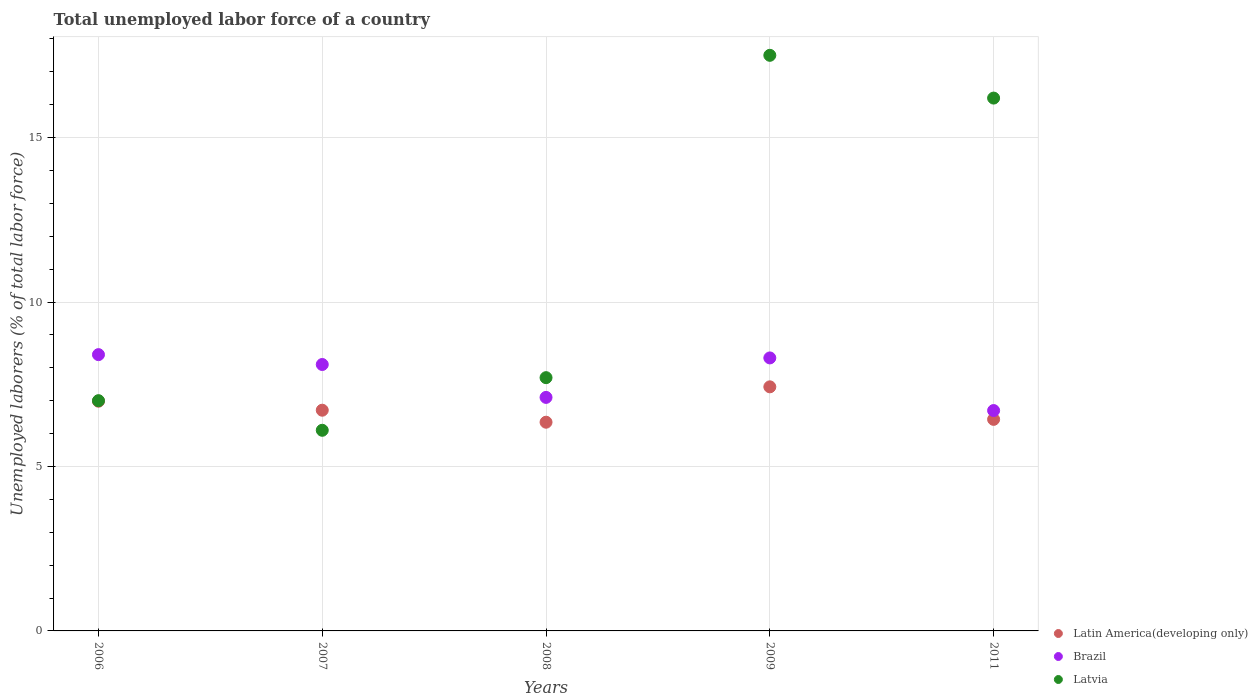How many different coloured dotlines are there?
Provide a short and direct response. 3. Is the number of dotlines equal to the number of legend labels?
Keep it short and to the point. Yes. What is the total unemployed labor force in Latin America(developing only) in 2011?
Offer a terse response. 6.43. Across all years, what is the maximum total unemployed labor force in Brazil?
Give a very brief answer. 8.4. Across all years, what is the minimum total unemployed labor force in Latin America(developing only)?
Ensure brevity in your answer.  6.35. In which year was the total unemployed labor force in Latvia maximum?
Your answer should be compact. 2009. In which year was the total unemployed labor force in Brazil minimum?
Keep it short and to the point. 2011. What is the total total unemployed labor force in Brazil in the graph?
Provide a succinct answer. 38.6. What is the difference between the total unemployed labor force in Latvia in 2006 and that in 2008?
Keep it short and to the point. -0.7. What is the difference between the total unemployed labor force in Brazil in 2006 and the total unemployed labor force in Latvia in 2007?
Offer a terse response. 2.3. What is the average total unemployed labor force in Latvia per year?
Ensure brevity in your answer.  10.9. In the year 2007, what is the difference between the total unemployed labor force in Brazil and total unemployed labor force in Latvia?
Your response must be concise. 2. In how many years, is the total unemployed labor force in Latvia greater than 1 %?
Your response must be concise. 5. What is the ratio of the total unemployed labor force in Latvia in 2009 to that in 2011?
Offer a very short reply. 1.08. Is the difference between the total unemployed labor force in Brazil in 2007 and 2008 greater than the difference between the total unemployed labor force in Latvia in 2007 and 2008?
Offer a terse response. Yes. What is the difference between the highest and the second highest total unemployed labor force in Latvia?
Provide a succinct answer. 1.3. What is the difference between the highest and the lowest total unemployed labor force in Latvia?
Give a very brief answer. 11.4. Is the sum of the total unemployed labor force in Brazil in 2007 and 2008 greater than the maximum total unemployed labor force in Latin America(developing only) across all years?
Your response must be concise. Yes. Is it the case that in every year, the sum of the total unemployed labor force in Brazil and total unemployed labor force in Latvia  is greater than the total unemployed labor force in Latin America(developing only)?
Keep it short and to the point. Yes. Is the total unemployed labor force in Brazil strictly greater than the total unemployed labor force in Latvia over the years?
Make the answer very short. No. Is the total unemployed labor force in Latvia strictly less than the total unemployed labor force in Latin America(developing only) over the years?
Your answer should be compact. No. How many dotlines are there?
Ensure brevity in your answer.  3. How many years are there in the graph?
Your response must be concise. 5. Does the graph contain any zero values?
Provide a succinct answer. No. Where does the legend appear in the graph?
Ensure brevity in your answer.  Bottom right. How are the legend labels stacked?
Provide a short and direct response. Vertical. What is the title of the graph?
Provide a short and direct response. Total unemployed labor force of a country. Does "Sub-Saharan Africa (all income levels)" appear as one of the legend labels in the graph?
Give a very brief answer. No. What is the label or title of the Y-axis?
Provide a succinct answer. Unemployed laborers (% of total labor force). What is the Unemployed laborers (% of total labor force) of Latin America(developing only) in 2006?
Keep it short and to the point. 6.98. What is the Unemployed laborers (% of total labor force) of Brazil in 2006?
Keep it short and to the point. 8.4. What is the Unemployed laborers (% of total labor force) in Latin America(developing only) in 2007?
Offer a terse response. 6.71. What is the Unemployed laborers (% of total labor force) of Brazil in 2007?
Give a very brief answer. 8.1. What is the Unemployed laborers (% of total labor force) of Latvia in 2007?
Ensure brevity in your answer.  6.1. What is the Unemployed laborers (% of total labor force) in Latin America(developing only) in 2008?
Make the answer very short. 6.35. What is the Unemployed laborers (% of total labor force) in Brazil in 2008?
Your answer should be very brief. 7.1. What is the Unemployed laborers (% of total labor force) of Latvia in 2008?
Provide a succinct answer. 7.7. What is the Unemployed laborers (% of total labor force) in Latin America(developing only) in 2009?
Your answer should be very brief. 7.42. What is the Unemployed laborers (% of total labor force) of Brazil in 2009?
Offer a very short reply. 8.3. What is the Unemployed laborers (% of total labor force) in Latin America(developing only) in 2011?
Offer a terse response. 6.43. What is the Unemployed laborers (% of total labor force) in Brazil in 2011?
Your response must be concise. 6.7. What is the Unemployed laborers (% of total labor force) in Latvia in 2011?
Give a very brief answer. 16.2. Across all years, what is the maximum Unemployed laborers (% of total labor force) in Latin America(developing only)?
Your answer should be very brief. 7.42. Across all years, what is the maximum Unemployed laborers (% of total labor force) in Brazil?
Provide a succinct answer. 8.4. Across all years, what is the maximum Unemployed laborers (% of total labor force) of Latvia?
Your answer should be very brief. 17.5. Across all years, what is the minimum Unemployed laborers (% of total labor force) of Latin America(developing only)?
Your answer should be very brief. 6.35. Across all years, what is the minimum Unemployed laborers (% of total labor force) in Brazil?
Offer a terse response. 6.7. Across all years, what is the minimum Unemployed laborers (% of total labor force) of Latvia?
Make the answer very short. 6.1. What is the total Unemployed laborers (% of total labor force) in Latin America(developing only) in the graph?
Your answer should be compact. 33.89. What is the total Unemployed laborers (% of total labor force) in Brazil in the graph?
Give a very brief answer. 38.6. What is the total Unemployed laborers (% of total labor force) in Latvia in the graph?
Make the answer very short. 54.5. What is the difference between the Unemployed laborers (% of total labor force) in Latin America(developing only) in 2006 and that in 2007?
Give a very brief answer. 0.27. What is the difference between the Unemployed laborers (% of total labor force) in Brazil in 2006 and that in 2007?
Ensure brevity in your answer.  0.3. What is the difference between the Unemployed laborers (% of total labor force) in Latvia in 2006 and that in 2007?
Make the answer very short. 0.9. What is the difference between the Unemployed laborers (% of total labor force) of Latin America(developing only) in 2006 and that in 2008?
Provide a succinct answer. 0.64. What is the difference between the Unemployed laborers (% of total labor force) in Brazil in 2006 and that in 2008?
Offer a very short reply. 1.3. What is the difference between the Unemployed laborers (% of total labor force) in Latin America(developing only) in 2006 and that in 2009?
Your response must be concise. -0.44. What is the difference between the Unemployed laborers (% of total labor force) of Latin America(developing only) in 2006 and that in 2011?
Offer a terse response. 0.55. What is the difference between the Unemployed laborers (% of total labor force) in Brazil in 2006 and that in 2011?
Provide a short and direct response. 1.7. What is the difference between the Unemployed laborers (% of total labor force) of Latin America(developing only) in 2007 and that in 2008?
Offer a terse response. 0.36. What is the difference between the Unemployed laborers (% of total labor force) in Brazil in 2007 and that in 2008?
Your response must be concise. 1. What is the difference between the Unemployed laborers (% of total labor force) in Latvia in 2007 and that in 2008?
Ensure brevity in your answer.  -1.6. What is the difference between the Unemployed laborers (% of total labor force) in Latin America(developing only) in 2007 and that in 2009?
Ensure brevity in your answer.  -0.71. What is the difference between the Unemployed laborers (% of total labor force) of Latin America(developing only) in 2007 and that in 2011?
Make the answer very short. 0.28. What is the difference between the Unemployed laborers (% of total labor force) of Latin America(developing only) in 2008 and that in 2009?
Make the answer very short. -1.08. What is the difference between the Unemployed laborers (% of total labor force) in Brazil in 2008 and that in 2009?
Ensure brevity in your answer.  -1.2. What is the difference between the Unemployed laborers (% of total labor force) of Latvia in 2008 and that in 2009?
Your answer should be compact. -9.8. What is the difference between the Unemployed laborers (% of total labor force) in Latin America(developing only) in 2008 and that in 2011?
Offer a very short reply. -0.09. What is the difference between the Unemployed laborers (% of total labor force) in Brazil in 2008 and that in 2011?
Keep it short and to the point. 0.4. What is the difference between the Unemployed laborers (% of total labor force) of Latin America(developing only) in 2006 and the Unemployed laborers (% of total labor force) of Brazil in 2007?
Offer a terse response. -1.12. What is the difference between the Unemployed laborers (% of total labor force) of Latin America(developing only) in 2006 and the Unemployed laborers (% of total labor force) of Latvia in 2007?
Provide a short and direct response. 0.88. What is the difference between the Unemployed laborers (% of total labor force) of Brazil in 2006 and the Unemployed laborers (% of total labor force) of Latvia in 2007?
Offer a terse response. 2.3. What is the difference between the Unemployed laborers (% of total labor force) in Latin America(developing only) in 2006 and the Unemployed laborers (% of total labor force) in Brazil in 2008?
Provide a succinct answer. -0.12. What is the difference between the Unemployed laborers (% of total labor force) of Latin America(developing only) in 2006 and the Unemployed laborers (% of total labor force) of Latvia in 2008?
Ensure brevity in your answer.  -0.72. What is the difference between the Unemployed laborers (% of total labor force) in Latin America(developing only) in 2006 and the Unemployed laborers (% of total labor force) in Brazil in 2009?
Offer a terse response. -1.32. What is the difference between the Unemployed laborers (% of total labor force) of Latin America(developing only) in 2006 and the Unemployed laborers (% of total labor force) of Latvia in 2009?
Provide a short and direct response. -10.52. What is the difference between the Unemployed laborers (% of total labor force) of Brazil in 2006 and the Unemployed laborers (% of total labor force) of Latvia in 2009?
Keep it short and to the point. -9.1. What is the difference between the Unemployed laborers (% of total labor force) of Latin America(developing only) in 2006 and the Unemployed laborers (% of total labor force) of Brazil in 2011?
Offer a very short reply. 0.28. What is the difference between the Unemployed laborers (% of total labor force) in Latin America(developing only) in 2006 and the Unemployed laborers (% of total labor force) in Latvia in 2011?
Provide a succinct answer. -9.22. What is the difference between the Unemployed laborers (% of total labor force) of Latin America(developing only) in 2007 and the Unemployed laborers (% of total labor force) of Brazil in 2008?
Keep it short and to the point. -0.39. What is the difference between the Unemployed laborers (% of total labor force) in Latin America(developing only) in 2007 and the Unemployed laborers (% of total labor force) in Latvia in 2008?
Your answer should be compact. -0.99. What is the difference between the Unemployed laborers (% of total labor force) in Brazil in 2007 and the Unemployed laborers (% of total labor force) in Latvia in 2008?
Your answer should be very brief. 0.4. What is the difference between the Unemployed laborers (% of total labor force) of Latin America(developing only) in 2007 and the Unemployed laborers (% of total labor force) of Brazil in 2009?
Keep it short and to the point. -1.59. What is the difference between the Unemployed laborers (% of total labor force) in Latin America(developing only) in 2007 and the Unemployed laborers (% of total labor force) in Latvia in 2009?
Keep it short and to the point. -10.79. What is the difference between the Unemployed laborers (% of total labor force) of Brazil in 2007 and the Unemployed laborers (% of total labor force) of Latvia in 2009?
Your response must be concise. -9.4. What is the difference between the Unemployed laborers (% of total labor force) of Latin America(developing only) in 2007 and the Unemployed laborers (% of total labor force) of Brazil in 2011?
Your response must be concise. 0.01. What is the difference between the Unemployed laborers (% of total labor force) in Latin America(developing only) in 2007 and the Unemployed laborers (% of total labor force) in Latvia in 2011?
Your answer should be compact. -9.49. What is the difference between the Unemployed laborers (% of total labor force) of Latin America(developing only) in 2008 and the Unemployed laborers (% of total labor force) of Brazil in 2009?
Your answer should be compact. -1.95. What is the difference between the Unemployed laborers (% of total labor force) of Latin America(developing only) in 2008 and the Unemployed laborers (% of total labor force) of Latvia in 2009?
Your response must be concise. -11.15. What is the difference between the Unemployed laborers (% of total labor force) in Latin America(developing only) in 2008 and the Unemployed laborers (% of total labor force) in Brazil in 2011?
Your answer should be compact. -0.35. What is the difference between the Unemployed laborers (% of total labor force) of Latin America(developing only) in 2008 and the Unemployed laborers (% of total labor force) of Latvia in 2011?
Offer a terse response. -9.85. What is the difference between the Unemployed laborers (% of total labor force) in Brazil in 2008 and the Unemployed laborers (% of total labor force) in Latvia in 2011?
Offer a terse response. -9.1. What is the difference between the Unemployed laborers (% of total labor force) of Latin America(developing only) in 2009 and the Unemployed laborers (% of total labor force) of Brazil in 2011?
Ensure brevity in your answer.  0.72. What is the difference between the Unemployed laborers (% of total labor force) in Latin America(developing only) in 2009 and the Unemployed laborers (% of total labor force) in Latvia in 2011?
Your answer should be compact. -8.78. What is the difference between the Unemployed laborers (% of total labor force) in Brazil in 2009 and the Unemployed laborers (% of total labor force) in Latvia in 2011?
Make the answer very short. -7.9. What is the average Unemployed laborers (% of total labor force) in Latin America(developing only) per year?
Make the answer very short. 6.78. What is the average Unemployed laborers (% of total labor force) of Brazil per year?
Your answer should be very brief. 7.72. In the year 2006, what is the difference between the Unemployed laborers (% of total labor force) of Latin America(developing only) and Unemployed laborers (% of total labor force) of Brazil?
Offer a very short reply. -1.42. In the year 2006, what is the difference between the Unemployed laborers (% of total labor force) of Latin America(developing only) and Unemployed laborers (% of total labor force) of Latvia?
Provide a succinct answer. -0.02. In the year 2006, what is the difference between the Unemployed laborers (% of total labor force) of Brazil and Unemployed laborers (% of total labor force) of Latvia?
Give a very brief answer. 1.4. In the year 2007, what is the difference between the Unemployed laborers (% of total labor force) of Latin America(developing only) and Unemployed laborers (% of total labor force) of Brazil?
Provide a short and direct response. -1.39. In the year 2007, what is the difference between the Unemployed laborers (% of total labor force) of Latin America(developing only) and Unemployed laborers (% of total labor force) of Latvia?
Provide a short and direct response. 0.61. In the year 2007, what is the difference between the Unemployed laborers (% of total labor force) of Brazil and Unemployed laborers (% of total labor force) of Latvia?
Your answer should be compact. 2. In the year 2008, what is the difference between the Unemployed laborers (% of total labor force) of Latin America(developing only) and Unemployed laborers (% of total labor force) of Brazil?
Your answer should be compact. -0.75. In the year 2008, what is the difference between the Unemployed laborers (% of total labor force) of Latin America(developing only) and Unemployed laborers (% of total labor force) of Latvia?
Offer a very short reply. -1.35. In the year 2009, what is the difference between the Unemployed laborers (% of total labor force) of Latin America(developing only) and Unemployed laborers (% of total labor force) of Brazil?
Your answer should be very brief. -0.88. In the year 2009, what is the difference between the Unemployed laborers (% of total labor force) of Latin America(developing only) and Unemployed laborers (% of total labor force) of Latvia?
Your answer should be compact. -10.08. In the year 2011, what is the difference between the Unemployed laborers (% of total labor force) of Latin America(developing only) and Unemployed laborers (% of total labor force) of Brazil?
Make the answer very short. -0.27. In the year 2011, what is the difference between the Unemployed laborers (% of total labor force) of Latin America(developing only) and Unemployed laborers (% of total labor force) of Latvia?
Provide a succinct answer. -9.77. What is the ratio of the Unemployed laborers (% of total labor force) in Latin America(developing only) in 2006 to that in 2007?
Your answer should be compact. 1.04. What is the ratio of the Unemployed laborers (% of total labor force) of Brazil in 2006 to that in 2007?
Provide a short and direct response. 1.04. What is the ratio of the Unemployed laborers (% of total labor force) in Latvia in 2006 to that in 2007?
Give a very brief answer. 1.15. What is the ratio of the Unemployed laborers (% of total labor force) of Latin America(developing only) in 2006 to that in 2008?
Make the answer very short. 1.1. What is the ratio of the Unemployed laborers (% of total labor force) of Brazil in 2006 to that in 2008?
Offer a terse response. 1.18. What is the ratio of the Unemployed laborers (% of total labor force) of Latvia in 2006 to that in 2008?
Offer a terse response. 0.91. What is the ratio of the Unemployed laborers (% of total labor force) in Latin America(developing only) in 2006 to that in 2009?
Your response must be concise. 0.94. What is the ratio of the Unemployed laborers (% of total labor force) of Brazil in 2006 to that in 2009?
Provide a succinct answer. 1.01. What is the ratio of the Unemployed laborers (% of total labor force) of Latin America(developing only) in 2006 to that in 2011?
Your answer should be very brief. 1.09. What is the ratio of the Unemployed laborers (% of total labor force) in Brazil in 2006 to that in 2011?
Provide a succinct answer. 1.25. What is the ratio of the Unemployed laborers (% of total labor force) of Latvia in 2006 to that in 2011?
Keep it short and to the point. 0.43. What is the ratio of the Unemployed laborers (% of total labor force) of Latin America(developing only) in 2007 to that in 2008?
Your answer should be very brief. 1.06. What is the ratio of the Unemployed laborers (% of total labor force) in Brazil in 2007 to that in 2008?
Provide a succinct answer. 1.14. What is the ratio of the Unemployed laborers (% of total labor force) in Latvia in 2007 to that in 2008?
Your response must be concise. 0.79. What is the ratio of the Unemployed laborers (% of total labor force) in Latin America(developing only) in 2007 to that in 2009?
Keep it short and to the point. 0.9. What is the ratio of the Unemployed laborers (% of total labor force) in Brazil in 2007 to that in 2009?
Offer a very short reply. 0.98. What is the ratio of the Unemployed laborers (% of total labor force) of Latvia in 2007 to that in 2009?
Ensure brevity in your answer.  0.35. What is the ratio of the Unemployed laborers (% of total labor force) of Latin America(developing only) in 2007 to that in 2011?
Ensure brevity in your answer.  1.04. What is the ratio of the Unemployed laborers (% of total labor force) in Brazil in 2007 to that in 2011?
Keep it short and to the point. 1.21. What is the ratio of the Unemployed laborers (% of total labor force) of Latvia in 2007 to that in 2011?
Provide a succinct answer. 0.38. What is the ratio of the Unemployed laborers (% of total labor force) in Latin America(developing only) in 2008 to that in 2009?
Provide a succinct answer. 0.86. What is the ratio of the Unemployed laborers (% of total labor force) of Brazil in 2008 to that in 2009?
Keep it short and to the point. 0.86. What is the ratio of the Unemployed laborers (% of total labor force) of Latvia in 2008 to that in 2009?
Keep it short and to the point. 0.44. What is the ratio of the Unemployed laborers (% of total labor force) in Latin America(developing only) in 2008 to that in 2011?
Provide a succinct answer. 0.99. What is the ratio of the Unemployed laborers (% of total labor force) in Brazil in 2008 to that in 2011?
Offer a very short reply. 1.06. What is the ratio of the Unemployed laborers (% of total labor force) in Latvia in 2008 to that in 2011?
Give a very brief answer. 0.48. What is the ratio of the Unemployed laborers (% of total labor force) in Latin America(developing only) in 2009 to that in 2011?
Give a very brief answer. 1.15. What is the ratio of the Unemployed laborers (% of total labor force) in Brazil in 2009 to that in 2011?
Keep it short and to the point. 1.24. What is the ratio of the Unemployed laborers (% of total labor force) in Latvia in 2009 to that in 2011?
Provide a short and direct response. 1.08. What is the difference between the highest and the second highest Unemployed laborers (% of total labor force) in Latin America(developing only)?
Your response must be concise. 0.44. What is the difference between the highest and the second highest Unemployed laborers (% of total labor force) of Brazil?
Your answer should be compact. 0.1. What is the difference between the highest and the lowest Unemployed laborers (% of total labor force) in Latin America(developing only)?
Keep it short and to the point. 1.08. What is the difference between the highest and the lowest Unemployed laborers (% of total labor force) of Brazil?
Give a very brief answer. 1.7. What is the difference between the highest and the lowest Unemployed laborers (% of total labor force) of Latvia?
Your answer should be very brief. 11.4. 